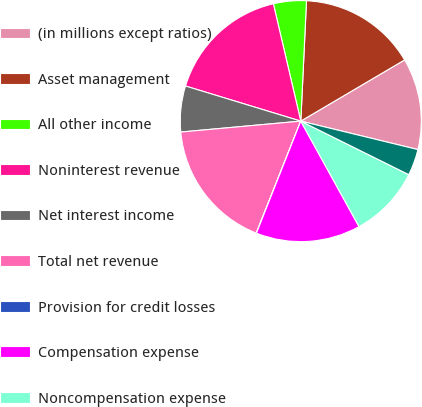Convert chart. <chart><loc_0><loc_0><loc_500><loc_500><pie_chart><fcel>(in millions except ratios)<fcel>Asset management<fcel>All other income<fcel>Noninterest revenue<fcel>Net interest income<fcel>Total net revenue<fcel>Provision for credit losses<fcel>Compensation expense<fcel>Noncompensation expense<fcel>Amortization of intangibles<nl><fcel>12.27%<fcel>15.77%<fcel>4.41%<fcel>16.64%<fcel>6.15%<fcel>17.52%<fcel>0.04%<fcel>14.02%<fcel>9.65%<fcel>3.53%<nl></chart> 